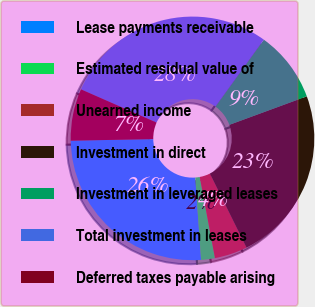<chart> <loc_0><loc_0><loc_500><loc_500><pie_chart><fcel>Lease payments receivable<fcel>Estimated residual value of<fcel>Unearned income<fcel>Investment in direct<fcel>Investment in leveraged leases<fcel>Total investment in leases<fcel>Deferred taxes payable arising<nl><fcel>25.83%<fcel>1.83%<fcel>4.36%<fcel>23.3%<fcel>9.43%<fcel>28.37%<fcel>6.89%<nl></chart> 